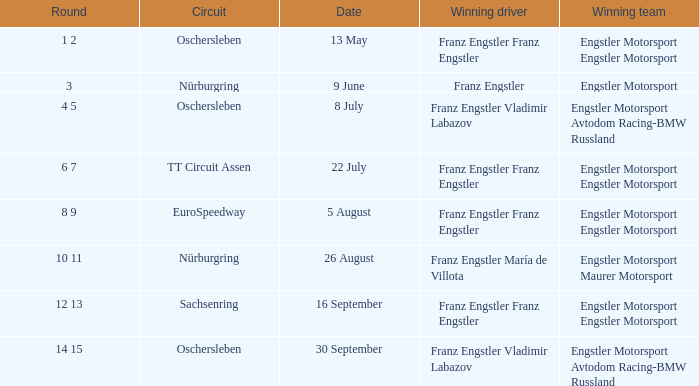What Winning team has 22 July as a Date? Engstler Motorsport Engstler Motorsport. 